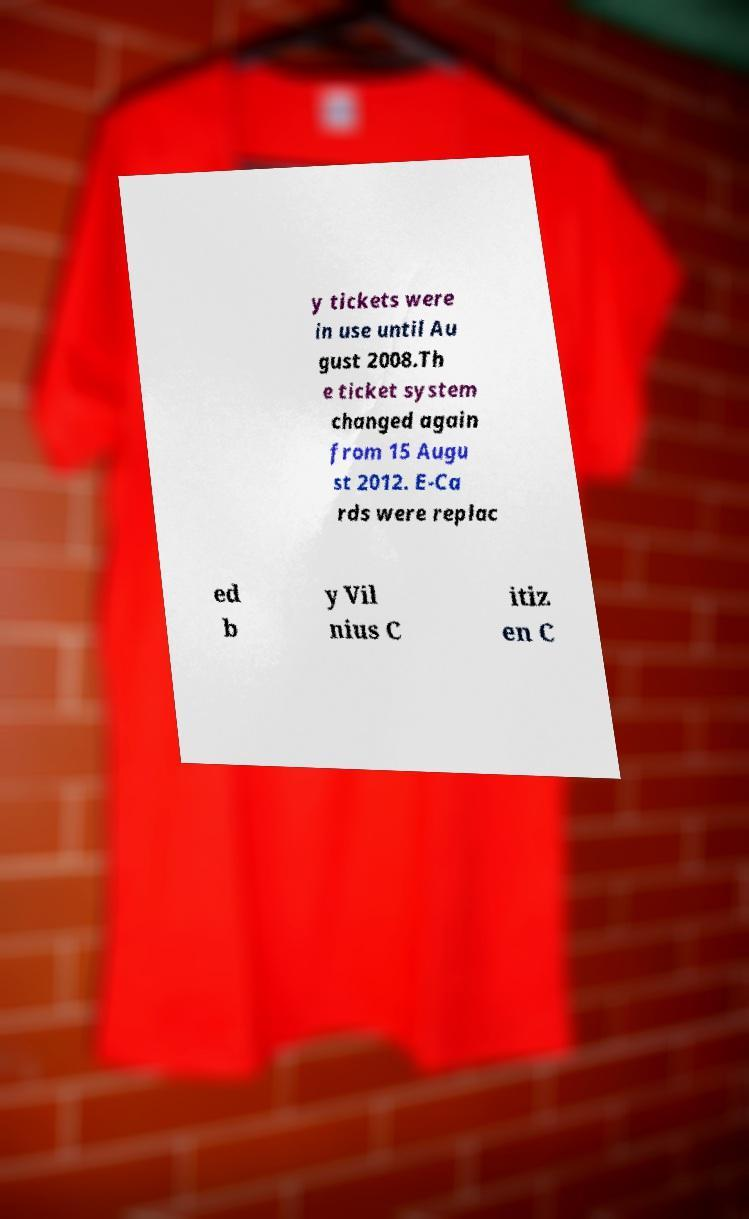For documentation purposes, I need the text within this image transcribed. Could you provide that? y tickets were in use until Au gust 2008.Th e ticket system changed again from 15 Augu st 2012. E-Ca rds were replac ed b y Vil nius C itiz en C 